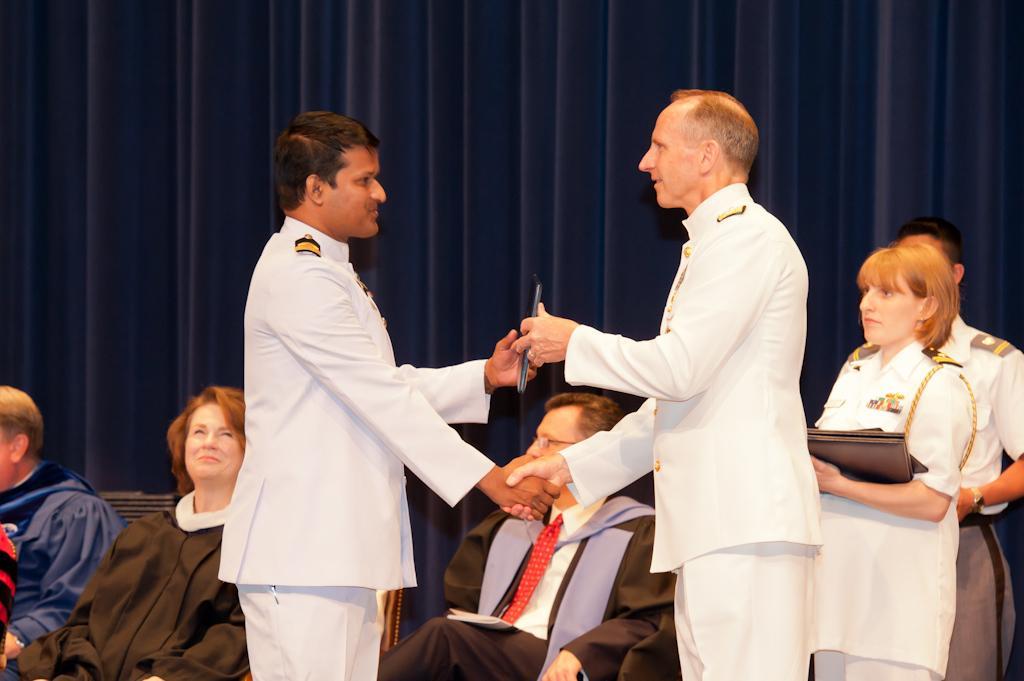Can you describe this image briefly? In this image in the foreground there are two people wearing white uniform. They are shaking hands and exchanging an object with each other. In the background three people are sitting. Here two other people are standing. The lady is holding something. In the background there is curtain. 